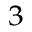<formula> <loc_0><loc_0><loc_500><loc_500>_ { 3 }</formula> 